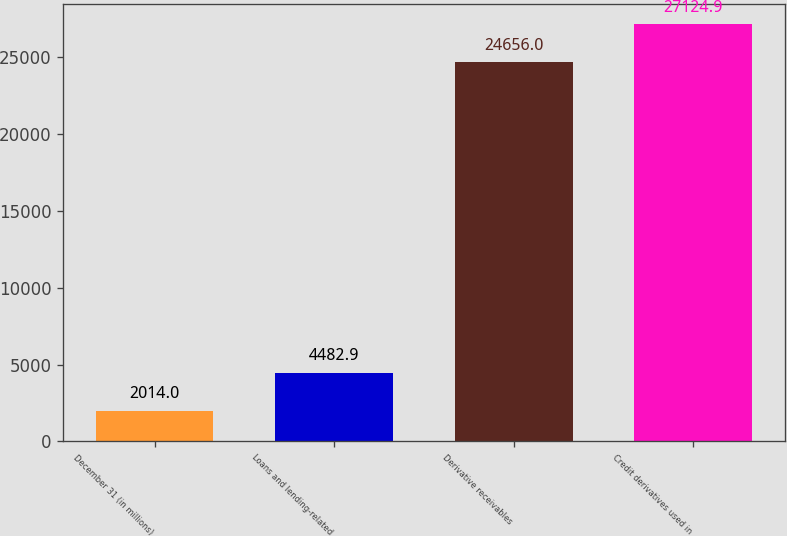Convert chart to OTSL. <chart><loc_0><loc_0><loc_500><loc_500><bar_chart><fcel>December 31 (in millions)<fcel>Loans and lending-related<fcel>Derivative receivables<fcel>Credit derivatives used in<nl><fcel>2014<fcel>4482.9<fcel>24656<fcel>27124.9<nl></chart> 